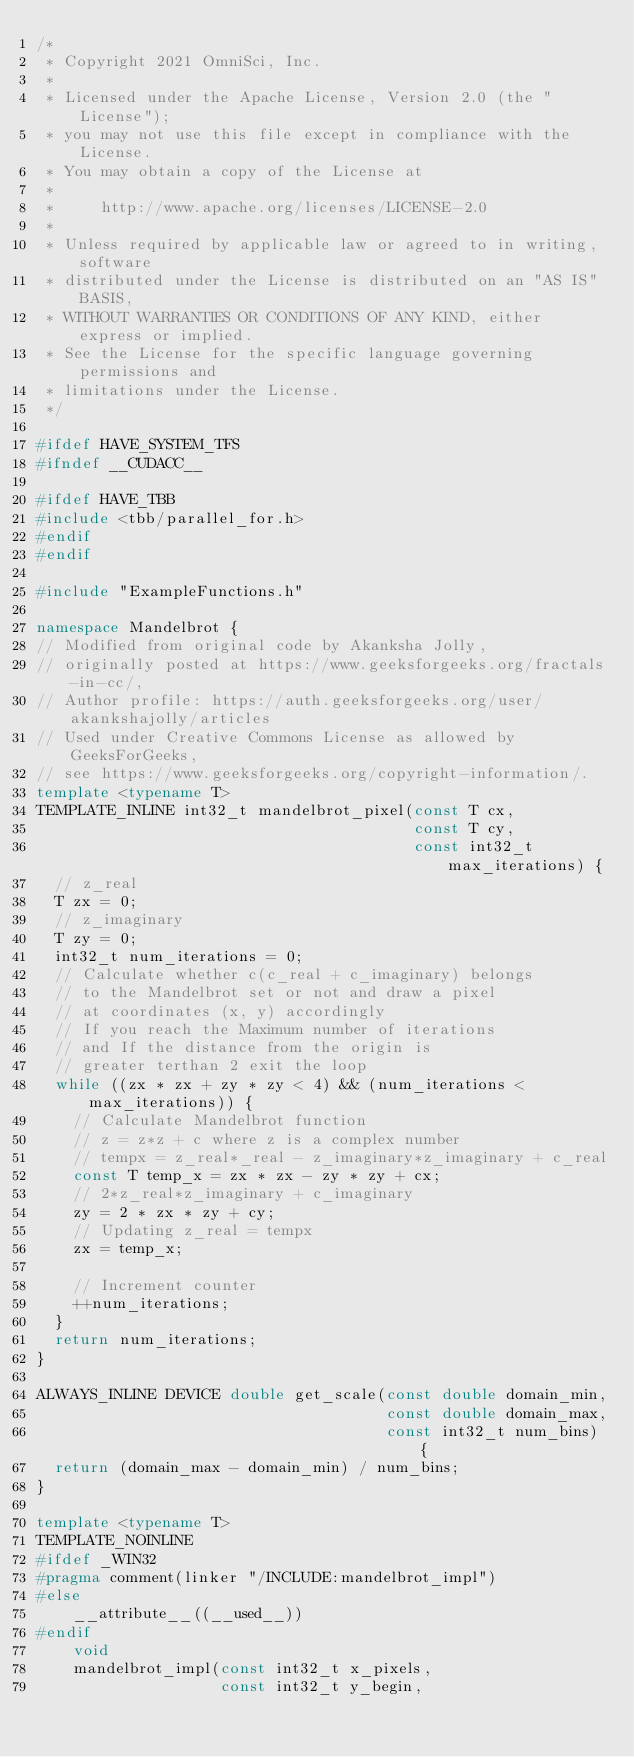Convert code to text. <code><loc_0><loc_0><loc_500><loc_500><_C++_>/*
 * Copyright 2021 OmniSci, Inc.
 *
 * Licensed under the Apache License, Version 2.0 (the "License");
 * you may not use this file except in compliance with the License.
 * You may obtain a copy of the License at
 *
 *     http://www.apache.org/licenses/LICENSE-2.0
 *
 * Unless required by applicable law or agreed to in writing, software
 * distributed under the License is distributed on an "AS IS" BASIS,
 * WITHOUT WARRANTIES OR CONDITIONS OF ANY KIND, either express or implied.
 * See the License for the specific language governing permissions and
 * limitations under the License.
 */

#ifdef HAVE_SYSTEM_TFS
#ifndef __CUDACC__

#ifdef HAVE_TBB
#include <tbb/parallel_for.h>
#endif
#endif

#include "ExampleFunctions.h"

namespace Mandelbrot {
// Modified from original code by Akanksha Jolly,
// originally posted at https://www.geeksforgeeks.org/fractals-in-cc/,
// Author profile: https://auth.geeksforgeeks.org/user/akankshajolly/articles
// Used under Creative Commons License as allowed by GeeksForGeeks,
// see https://www.geeksforgeeks.org/copyright-information/.
template <typename T>
TEMPLATE_INLINE int32_t mandelbrot_pixel(const T cx,
                                         const T cy,
                                         const int32_t max_iterations) {
  // z_real
  T zx = 0;
  // z_imaginary
  T zy = 0;
  int32_t num_iterations = 0;
  // Calculate whether c(c_real + c_imaginary) belongs
  // to the Mandelbrot set or not and draw a pixel
  // at coordinates (x, y) accordingly
  // If you reach the Maximum number of iterations
  // and If the distance from the origin is
  // greater terthan 2 exit the loop
  while ((zx * zx + zy * zy < 4) && (num_iterations < max_iterations)) {
    // Calculate Mandelbrot function
    // z = z*z + c where z is a complex number
    // tempx = z_real*_real - z_imaginary*z_imaginary + c_real
    const T temp_x = zx * zx - zy * zy + cx;
    // 2*z_real*z_imaginary + c_imaginary
    zy = 2 * zx * zy + cy;
    // Updating z_real = tempx
    zx = temp_x;

    // Increment counter
    ++num_iterations;
  }
  return num_iterations;
}

ALWAYS_INLINE DEVICE double get_scale(const double domain_min,
                                      const double domain_max,
                                      const int32_t num_bins) {
  return (domain_max - domain_min) / num_bins;
}

template <typename T>
TEMPLATE_NOINLINE
#ifdef _WIN32
#pragma comment(linker "/INCLUDE:mandelbrot_impl")
#else
    __attribute__((__used__))
#endif
    void
    mandelbrot_impl(const int32_t x_pixels,
                    const int32_t y_begin,</code> 